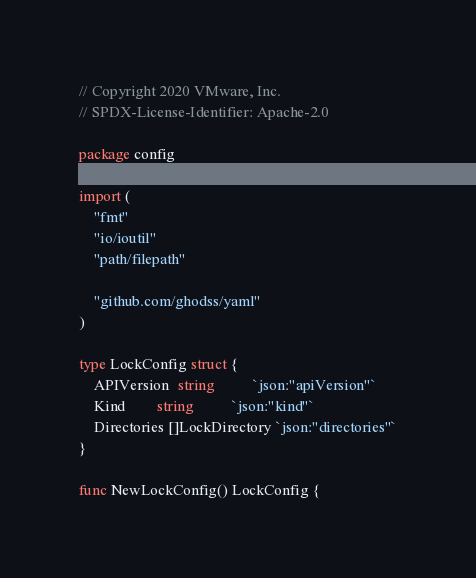<code> <loc_0><loc_0><loc_500><loc_500><_Go_>// Copyright 2020 VMware, Inc.
// SPDX-License-Identifier: Apache-2.0

package config

import (
	"fmt"
	"io/ioutil"
	"path/filepath"

	"github.com/ghodss/yaml"
)

type LockConfig struct {
	APIVersion  string          `json:"apiVersion"`
	Kind        string          `json:"kind"`
	Directories []LockDirectory `json:"directories"`
}

func NewLockConfig() LockConfig {</code> 